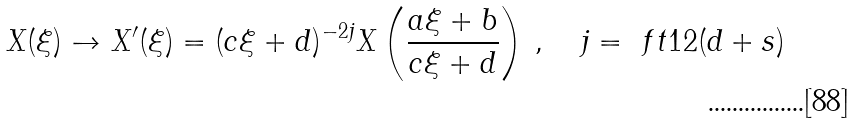Convert formula to latex. <formula><loc_0><loc_0><loc_500><loc_500>X ( \xi ) \to X ^ { \prime } ( \xi ) = ( c \xi + d ) ^ { - 2 j } X \left ( \frac { a \xi + b } { c \xi + d } \right ) \, , \quad j = \ f t 1 2 ( d + s )</formula> 